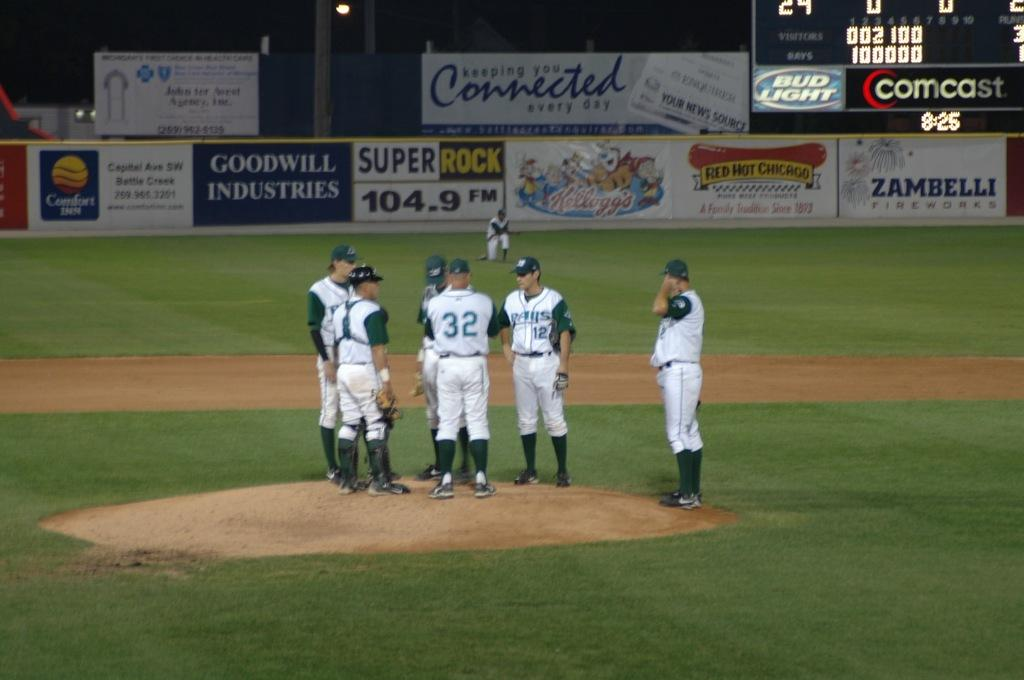<image>
Relay a brief, clear account of the picture shown. The Rays team meets on the dirt pitcher's mound. 